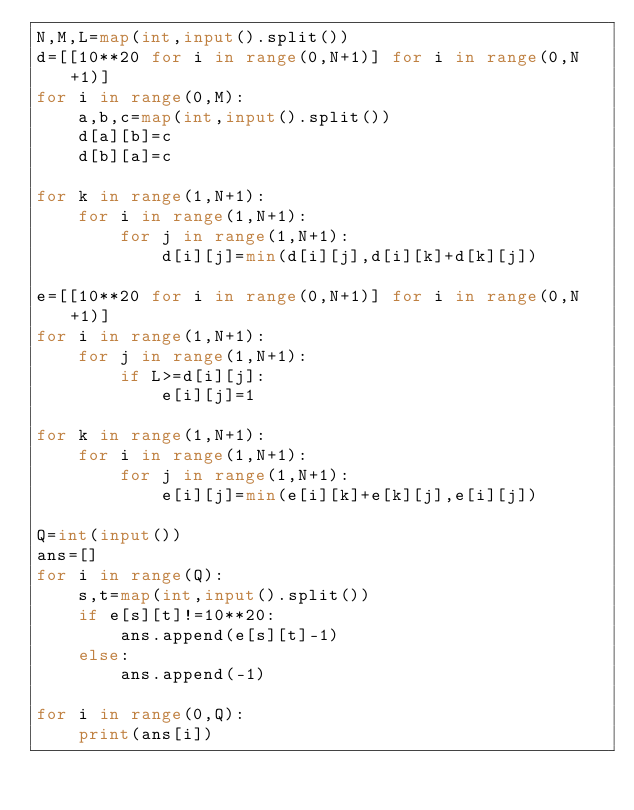Convert code to text. <code><loc_0><loc_0><loc_500><loc_500><_Python_>N,M,L=map(int,input().split())
d=[[10**20 for i in range(0,N+1)] for i in range(0,N+1)]
for i in range(0,M):
    a,b,c=map(int,input().split())
    d[a][b]=c
    d[b][a]=c

for k in range(1,N+1):
    for i in range(1,N+1):
        for j in range(1,N+1):
            d[i][j]=min(d[i][j],d[i][k]+d[k][j])

e=[[10**20 for i in range(0,N+1)] for i in range(0,N+1)]
for i in range(1,N+1):
    for j in range(1,N+1):
        if L>=d[i][j]:
            e[i][j]=1

for k in range(1,N+1):
    for i in range(1,N+1):
        for j in range(1,N+1):
            e[i][j]=min(e[i][k]+e[k][j],e[i][j])

Q=int(input())
ans=[]
for i in range(Q):
    s,t=map(int,input().split())
    if e[s][t]!=10**20:
        ans.append(e[s][t]-1)
    else:
        ans.append(-1)

for i in range(0,Q):
    print(ans[i])
</code> 